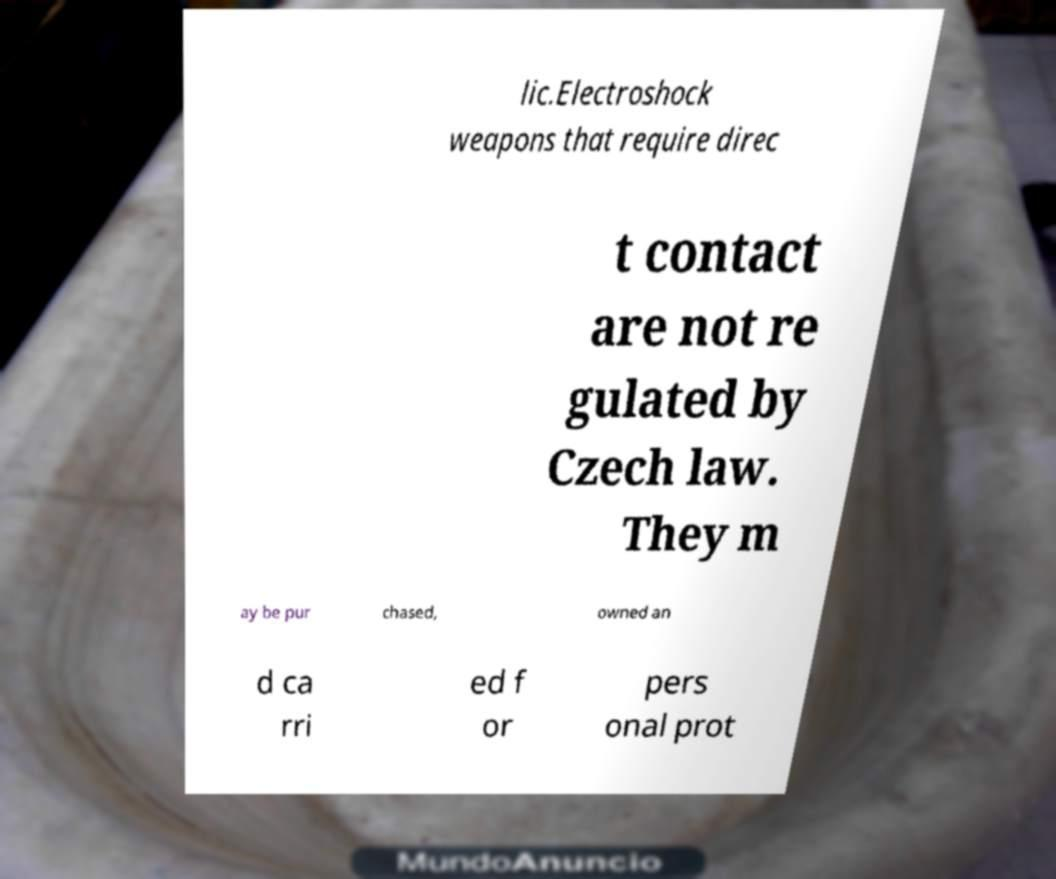Could you extract and type out the text from this image? lic.Electroshock weapons that require direc t contact are not re gulated by Czech law. They m ay be pur chased, owned an d ca rri ed f or pers onal prot 